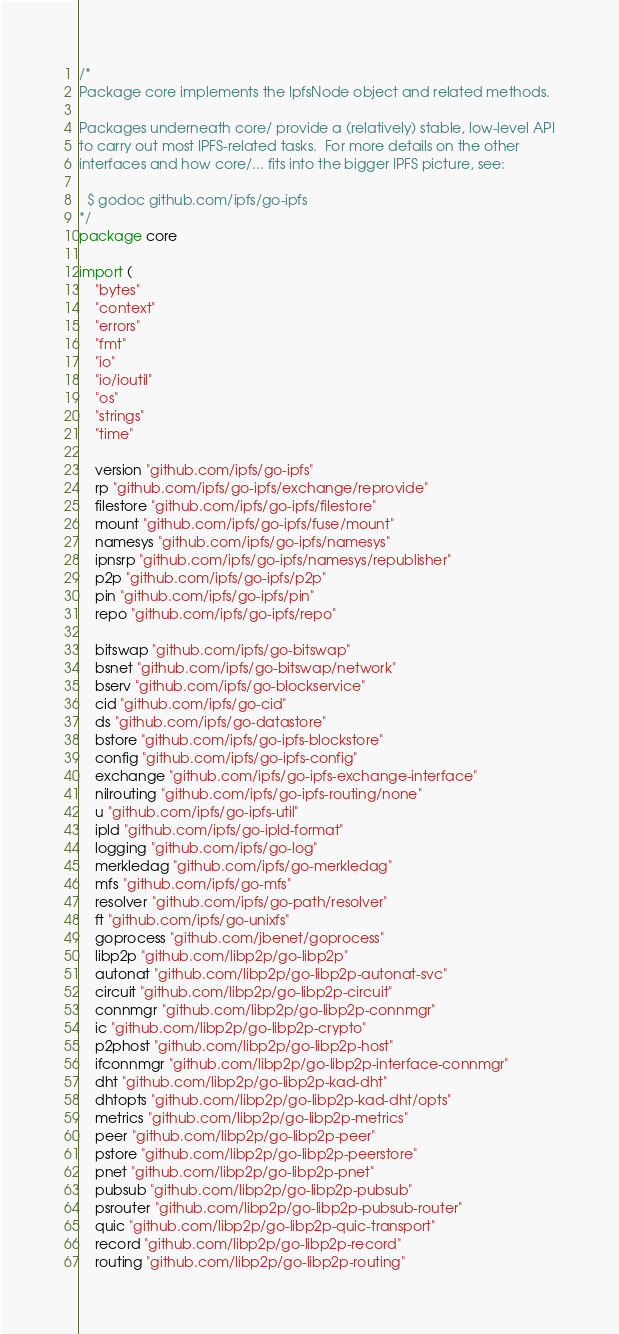<code> <loc_0><loc_0><loc_500><loc_500><_Go_>/*
Package core implements the IpfsNode object and related methods.

Packages underneath core/ provide a (relatively) stable, low-level API
to carry out most IPFS-related tasks.  For more details on the other
interfaces and how core/... fits into the bigger IPFS picture, see:

  $ godoc github.com/ipfs/go-ipfs
*/
package core

import (
	"bytes"
	"context"
	"errors"
	"fmt"
	"io"
	"io/ioutil"
	"os"
	"strings"
	"time"

	version "github.com/ipfs/go-ipfs"
	rp "github.com/ipfs/go-ipfs/exchange/reprovide"
	filestore "github.com/ipfs/go-ipfs/filestore"
	mount "github.com/ipfs/go-ipfs/fuse/mount"
	namesys "github.com/ipfs/go-ipfs/namesys"
	ipnsrp "github.com/ipfs/go-ipfs/namesys/republisher"
	p2p "github.com/ipfs/go-ipfs/p2p"
	pin "github.com/ipfs/go-ipfs/pin"
	repo "github.com/ipfs/go-ipfs/repo"

	bitswap "github.com/ipfs/go-bitswap"
	bsnet "github.com/ipfs/go-bitswap/network"
	bserv "github.com/ipfs/go-blockservice"
	cid "github.com/ipfs/go-cid"
	ds "github.com/ipfs/go-datastore"
	bstore "github.com/ipfs/go-ipfs-blockstore"
	config "github.com/ipfs/go-ipfs-config"
	exchange "github.com/ipfs/go-ipfs-exchange-interface"
	nilrouting "github.com/ipfs/go-ipfs-routing/none"
	u "github.com/ipfs/go-ipfs-util"
	ipld "github.com/ipfs/go-ipld-format"
	logging "github.com/ipfs/go-log"
	merkledag "github.com/ipfs/go-merkledag"
	mfs "github.com/ipfs/go-mfs"
	resolver "github.com/ipfs/go-path/resolver"
	ft "github.com/ipfs/go-unixfs"
	goprocess "github.com/jbenet/goprocess"
	libp2p "github.com/libp2p/go-libp2p"
	autonat "github.com/libp2p/go-libp2p-autonat-svc"
	circuit "github.com/libp2p/go-libp2p-circuit"
	connmgr "github.com/libp2p/go-libp2p-connmgr"
	ic "github.com/libp2p/go-libp2p-crypto"
	p2phost "github.com/libp2p/go-libp2p-host"
	ifconnmgr "github.com/libp2p/go-libp2p-interface-connmgr"
	dht "github.com/libp2p/go-libp2p-kad-dht"
	dhtopts "github.com/libp2p/go-libp2p-kad-dht/opts"
	metrics "github.com/libp2p/go-libp2p-metrics"
	peer "github.com/libp2p/go-libp2p-peer"
	pstore "github.com/libp2p/go-libp2p-peerstore"
	pnet "github.com/libp2p/go-libp2p-pnet"
	pubsub "github.com/libp2p/go-libp2p-pubsub"
	psrouter "github.com/libp2p/go-libp2p-pubsub-router"
	quic "github.com/libp2p/go-libp2p-quic-transport"
	record "github.com/libp2p/go-libp2p-record"
	routing "github.com/libp2p/go-libp2p-routing"</code> 